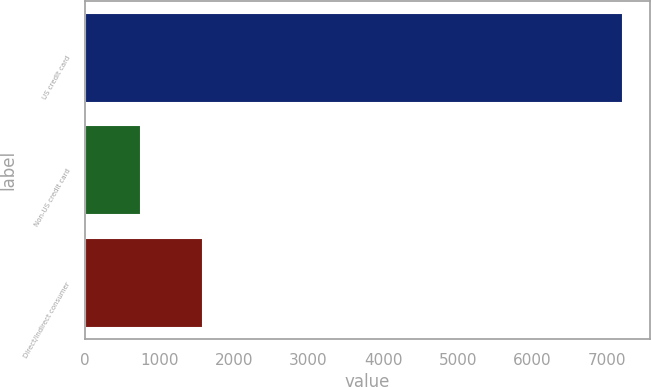<chart> <loc_0><loc_0><loc_500><loc_500><bar_chart><fcel>US credit card<fcel>Non-US credit card<fcel>Direct/Indirect consumer<nl><fcel>7211<fcel>759<fcel>1582<nl></chart> 